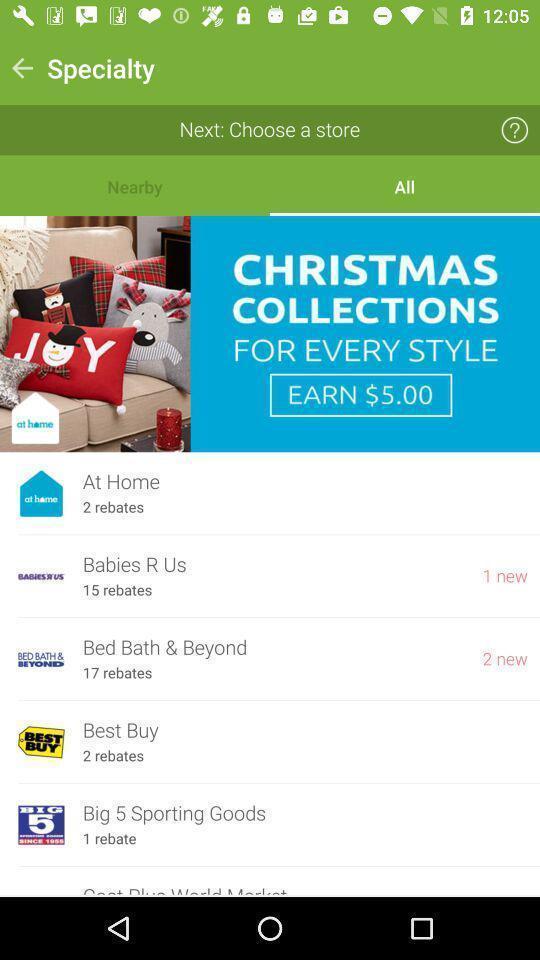Explain the elements present in this screenshot. Screen displaying the specialty page with list of options. 